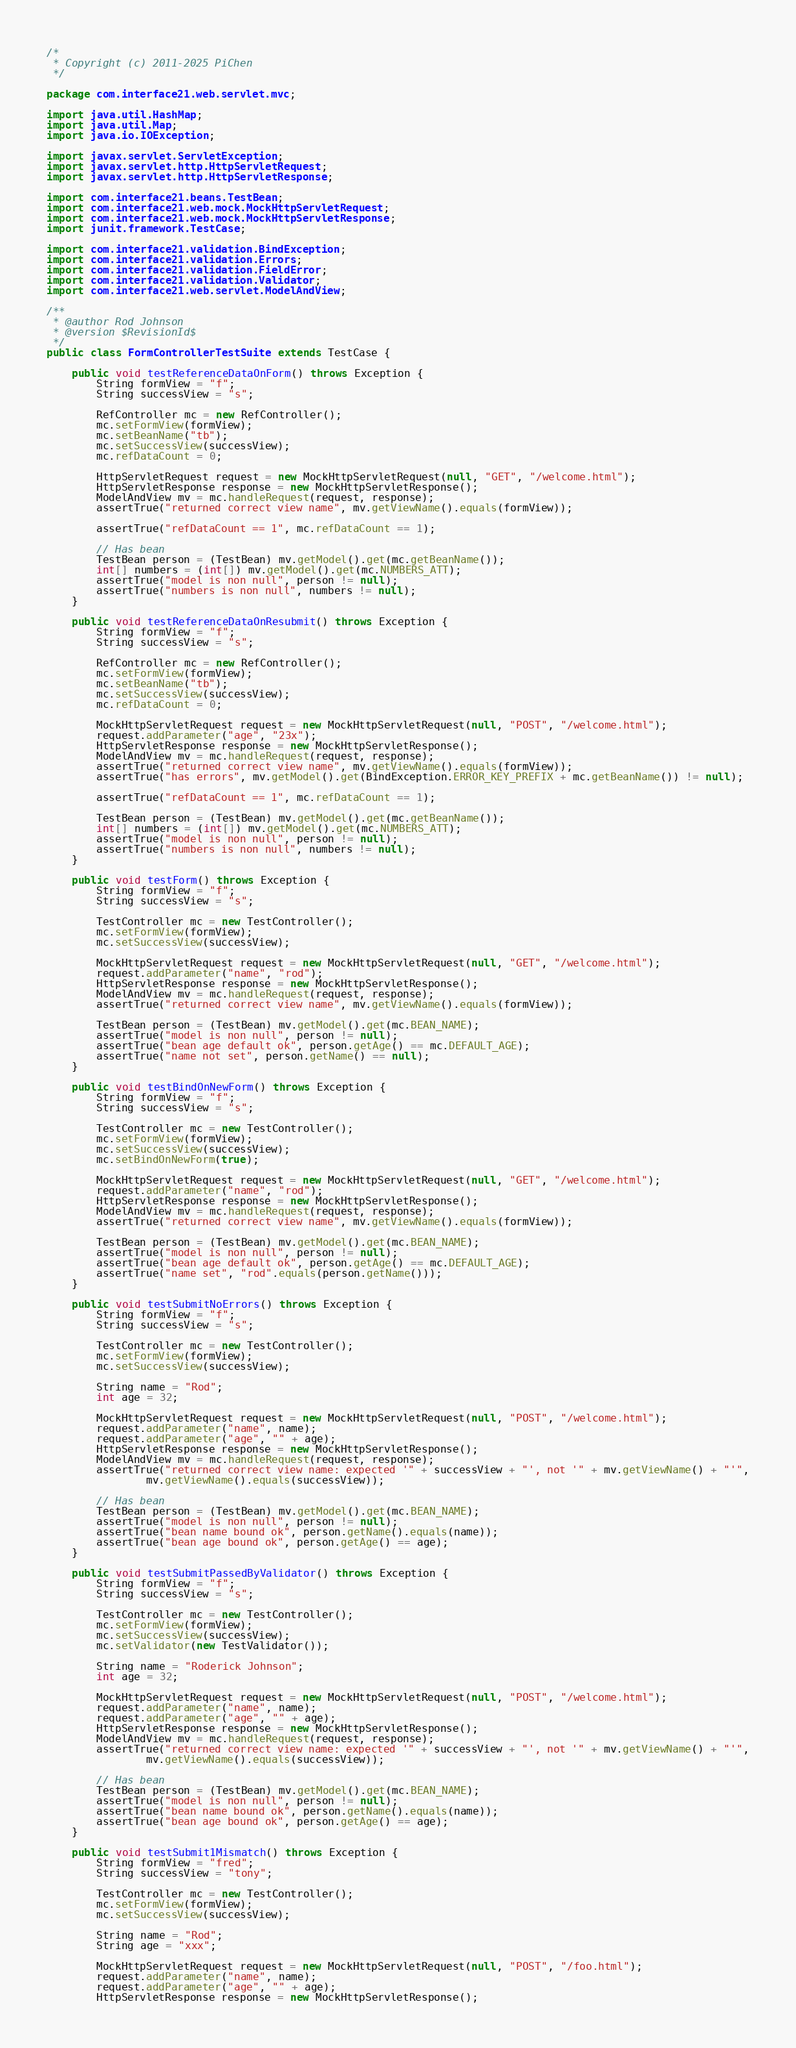<code> <loc_0><loc_0><loc_500><loc_500><_Java_>/*
 * Copyright (c) 2011-2025 PiChen
 */

package com.interface21.web.servlet.mvc;

import java.util.HashMap;
import java.util.Map;
import java.io.IOException;

import javax.servlet.ServletException;
import javax.servlet.http.HttpServletRequest;
import javax.servlet.http.HttpServletResponse;

import com.interface21.beans.TestBean;
import com.interface21.web.mock.MockHttpServletRequest;
import com.interface21.web.mock.MockHttpServletResponse;
import junit.framework.TestCase;

import com.interface21.validation.BindException;
import com.interface21.validation.Errors;
import com.interface21.validation.FieldError;
import com.interface21.validation.Validator;
import com.interface21.web.servlet.ModelAndView;

/**
 * @author Rod Johnson
 * @version $RevisionId$
 */
public class FormControllerTestSuite extends TestCase {

    public void testReferenceDataOnForm() throws Exception {
        String formView = "f";
        String successView = "s";

        RefController mc = new RefController();
        mc.setFormView(formView);
        mc.setBeanName("tb");
        mc.setSuccessView(successView);
        mc.refDataCount = 0;

        HttpServletRequest request = new MockHttpServletRequest(null, "GET", "/welcome.html");
        HttpServletResponse response = new MockHttpServletResponse();
        ModelAndView mv = mc.handleRequest(request, response);
        assertTrue("returned correct view name", mv.getViewName().equals(formView));

        assertTrue("refDataCount == 1", mc.refDataCount == 1);

        // Has bean
        TestBean person = (TestBean) mv.getModel().get(mc.getBeanName());
        int[] numbers = (int[]) mv.getModel().get(mc.NUMBERS_ATT);
        assertTrue("model is non null", person != null);
        assertTrue("numbers is non null", numbers != null);
    }

    public void testReferenceDataOnResubmit() throws Exception {
        String formView = "f";
        String successView = "s";

        RefController mc = new RefController();
        mc.setFormView(formView);
        mc.setBeanName("tb");
        mc.setSuccessView(successView);
        mc.refDataCount = 0;

        MockHttpServletRequest request = new MockHttpServletRequest(null, "POST", "/welcome.html");
        request.addParameter("age", "23x");
        HttpServletResponse response = new MockHttpServletResponse();
        ModelAndView mv = mc.handleRequest(request, response);
        assertTrue("returned correct view name", mv.getViewName().equals(formView));
        assertTrue("has errors", mv.getModel().get(BindException.ERROR_KEY_PREFIX + mc.getBeanName()) != null);

        assertTrue("refDataCount == 1", mc.refDataCount == 1);

        TestBean person = (TestBean) mv.getModel().get(mc.getBeanName());
        int[] numbers = (int[]) mv.getModel().get(mc.NUMBERS_ATT);
        assertTrue("model is non null", person != null);
        assertTrue("numbers is non null", numbers != null);
    }

    public void testForm() throws Exception {
        String formView = "f";
        String successView = "s";

        TestController mc = new TestController();
        mc.setFormView(formView);
        mc.setSuccessView(successView);

        MockHttpServletRequest request = new MockHttpServletRequest(null, "GET", "/welcome.html");
        request.addParameter("name", "rod");
        HttpServletResponse response = new MockHttpServletResponse();
        ModelAndView mv = mc.handleRequest(request, response);
        assertTrue("returned correct view name", mv.getViewName().equals(formView));

        TestBean person = (TestBean) mv.getModel().get(mc.BEAN_NAME);
        assertTrue("model is non null", person != null);
        assertTrue("bean age default ok", person.getAge() == mc.DEFAULT_AGE);
        assertTrue("name not set", person.getName() == null);
    }

    public void testBindOnNewForm() throws Exception {
        String formView = "f";
        String successView = "s";

        TestController mc = new TestController();
        mc.setFormView(formView);
        mc.setSuccessView(successView);
        mc.setBindOnNewForm(true);

        MockHttpServletRequest request = new MockHttpServletRequest(null, "GET", "/welcome.html");
        request.addParameter("name", "rod");
        HttpServletResponse response = new MockHttpServletResponse();
        ModelAndView mv = mc.handleRequest(request, response);
        assertTrue("returned correct view name", mv.getViewName().equals(formView));

        TestBean person = (TestBean) mv.getModel().get(mc.BEAN_NAME);
        assertTrue("model is non null", person != null);
        assertTrue("bean age default ok", person.getAge() == mc.DEFAULT_AGE);
        assertTrue("name set", "rod".equals(person.getName()));
    }

    public void testSubmitNoErrors() throws Exception {
        String formView = "f";
        String successView = "s";

        TestController mc = new TestController();
        mc.setFormView(formView);
        mc.setSuccessView(successView);

        String name = "Rod";
        int age = 32;

        MockHttpServletRequest request = new MockHttpServletRequest(null, "POST", "/welcome.html");
        request.addParameter("name", name);
        request.addParameter("age", "" + age);
        HttpServletResponse response = new MockHttpServletResponse();
        ModelAndView mv = mc.handleRequest(request, response);
        assertTrue("returned correct view name: expected '" + successView + "', not '" + mv.getViewName() + "'",
                mv.getViewName().equals(successView));

        // Has bean
        TestBean person = (TestBean) mv.getModel().get(mc.BEAN_NAME);
        assertTrue("model is non null", person != null);
        assertTrue("bean name bound ok", person.getName().equals(name));
        assertTrue("bean age bound ok", person.getAge() == age);
    }

    public void testSubmitPassedByValidator() throws Exception {
        String formView = "f";
        String successView = "s";

        TestController mc = new TestController();
        mc.setFormView(formView);
        mc.setSuccessView(successView);
        mc.setValidator(new TestValidator());

        String name = "Roderick Johnson";
        int age = 32;

        MockHttpServletRequest request = new MockHttpServletRequest(null, "POST", "/welcome.html");
        request.addParameter("name", name);
        request.addParameter("age", "" + age);
        HttpServletResponse response = new MockHttpServletResponse();
        ModelAndView mv = mc.handleRequest(request, response);
        assertTrue("returned correct view name: expected '" + successView + "', not '" + mv.getViewName() + "'",
                mv.getViewName().equals(successView));

        // Has bean
        TestBean person = (TestBean) mv.getModel().get(mc.BEAN_NAME);
        assertTrue("model is non null", person != null);
        assertTrue("bean name bound ok", person.getName().equals(name));
        assertTrue("bean age bound ok", person.getAge() == age);
    }

    public void testSubmit1Mismatch() throws Exception {
        String formView = "fred";
        String successView = "tony";

        TestController mc = new TestController();
        mc.setFormView(formView);
        mc.setSuccessView(successView);

        String name = "Rod";
        String age = "xxx";

        MockHttpServletRequest request = new MockHttpServletRequest(null, "POST", "/foo.html");
        request.addParameter("name", name);
        request.addParameter("age", "" + age);
        HttpServletResponse response = new MockHttpServletResponse();</code> 